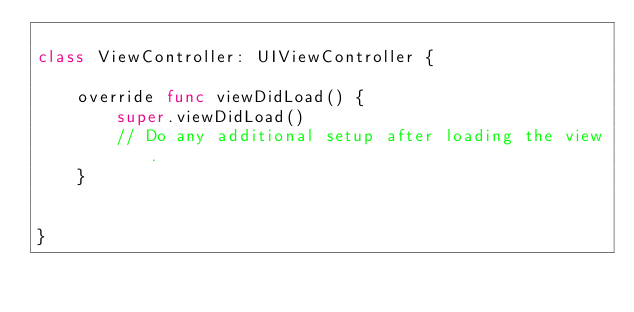Convert code to text. <code><loc_0><loc_0><loc_500><loc_500><_Swift_>
class ViewController: UIViewController {

    override func viewDidLoad() {
        super.viewDidLoad()
        // Do any additional setup after loading the view.
    }


}

</code> 